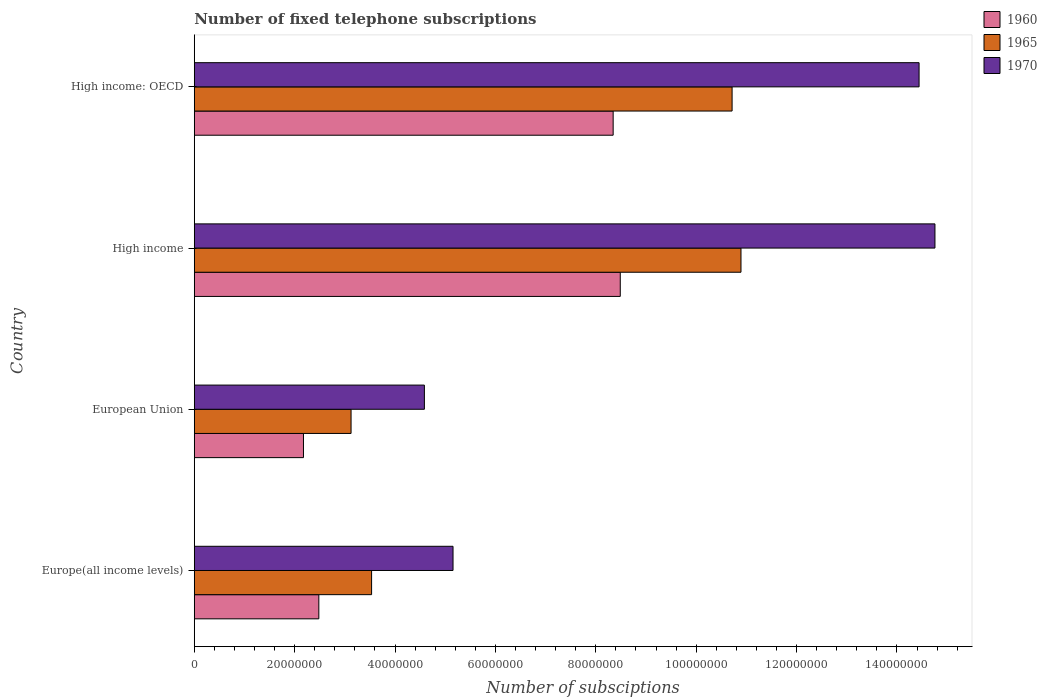How many different coloured bars are there?
Ensure brevity in your answer.  3. How many groups of bars are there?
Offer a terse response. 4. Are the number of bars on each tick of the Y-axis equal?
Your answer should be very brief. Yes. How many bars are there on the 1st tick from the top?
Your response must be concise. 3. What is the label of the 4th group of bars from the top?
Offer a very short reply. Europe(all income levels). What is the number of fixed telephone subscriptions in 1970 in European Union?
Keep it short and to the point. 4.59e+07. Across all countries, what is the maximum number of fixed telephone subscriptions in 1960?
Provide a short and direct response. 8.49e+07. Across all countries, what is the minimum number of fixed telephone subscriptions in 1965?
Provide a succinct answer. 3.12e+07. In which country was the number of fixed telephone subscriptions in 1960 maximum?
Ensure brevity in your answer.  High income. In which country was the number of fixed telephone subscriptions in 1970 minimum?
Your response must be concise. European Union. What is the total number of fixed telephone subscriptions in 1970 in the graph?
Give a very brief answer. 3.89e+08. What is the difference between the number of fixed telephone subscriptions in 1960 in Europe(all income levels) and that in High income?
Offer a terse response. -6.01e+07. What is the difference between the number of fixed telephone subscriptions in 1970 in High income: OECD and the number of fixed telephone subscriptions in 1965 in European Union?
Your answer should be compact. 1.13e+08. What is the average number of fixed telephone subscriptions in 1965 per country?
Make the answer very short. 7.07e+07. What is the difference between the number of fixed telephone subscriptions in 1960 and number of fixed telephone subscriptions in 1965 in European Union?
Make the answer very short. -9.48e+06. In how many countries, is the number of fixed telephone subscriptions in 1970 greater than 16000000 ?
Offer a very short reply. 4. What is the ratio of the number of fixed telephone subscriptions in 1965 in European Union to that in High income: OECD?
Keep it short and to the point. 0.29. Is the number of fixed telephone subscriptions in 1970 in Europe(all income levels) less than that in European Union?
Offer a terse response. No. What is the difference between the highest and the second highest number of fixed telephone subscriptions in 1965?
Offer a terse response. 1.77e+06. What is the difference between the highest and the lowest number of fixed telephone subscriptions in 1960?
Provide a succinct answer. 6.31e+07. Is the sum of the number of fixed telephone subscriptions in 1965 in High income and High income: OECD greater than the maximum number of fixed telephone subscriptions in 1970 across all countries?
Your response must be concise. Yes. What does the 2nd bar from the top in High income: OECD represents?
Make the answer very short. 1965. What does the 1st bar from the bottom in High income represents?
Ensure brevity in your answer.  1960. Is it the case that in every country, the sum of the number of fixed telephone subscriptions in 1970 and number of fixed telephone subscriptions in 1960 is greater than the number of fixed telephone subscriptions in 1965?
Offer a terse response. Yes. What is the difference between two consecutive major ticks on the X-axis?
Offer a very short reply. 2.00e+07. Are the values on the major ticks of X-axis written in scientific E-notation?
Your answer should be compact. No. Does the graph contain any zero values?
Provide a succinct answer. No. Does the graph contain grids?
Provide a short and direct response. No. How many legend labels are there?
Offer a terse response. 3. What is the title of the graph?
Keep it short and to the point. Number of fixed telephone subscriptions. What is the label or title of the X-axis?
Your response must be concise. Number of subsciptions. What is the Number of subsciptions of 1960 in Europe(all income levels)?
Provide a succinct answer. 2.48e+07. What is the Number of subsciptions in 1965 in Europe(all income levels)?
Offer a terse response. 3.53e+07. What is the Number of subsciptions in 1970 in Europe(all income levels)?
Offer a very short reply. 5.16e+07. What is the Number of subsciptions of 1960 in European Union?
Make the answer very short. 2.18e+07. What is the Number of subsciptions in 1965 in European Union?
Your answer should be very brief. 3.12e+07. What is the Number of subsciptions of 1970 in European Union?
Offer a very short reply. 4.59e+07. What is the Number of subsciptions in 1960 in High income?
Ensure brevity in your answer.  8.49e+07. What is the Number of subsciptions in 1965 in High income?
Your response must be concise. 1.09e+08. What is the Number of subsciptions in 1970 in High income?
Provide a short and direct response. 1.48e+08. What is the Number of subsciptions in 1960 in High income: OECD?
Your answer should be very brief. 8.35e+07. What is the Number of subsciptions in 1965 in High income: OECD?
Offer a terse response. 1.07e+08. What is the Number of subsciptions in 1970 in High income: OECD?
Keep it short and to the point. 1.44e+08. Across all countries, what is the maximum Number of subsciptions of 1960?
Provide a short and direct response. 8.49e+07. Across all countries, what is the maximum Number of subsciptions in 1965?
Provide a succinct answer. 1.09e+08. Across all countries, what is the maximum Number of subsciptions of 1970?
Provide a succinct answer. 1.48e+08. Across all countries, what is the minimum Number of subsciptions in 1960?
Provide a short and direct response. 2.18e+07. Across all countries, what is the minimum Number of subsciptions in 1965?
Your answer should be very brief. 3.12e+07. Across all countries, what is the minimum Number of subsciptions in 1970?
Ensure brevity in your answer.  4.59e+07. What is the total Number of subsciptions in 1960 in the graph?
Provide a short and direct response. 2.15e+08. What is the total Number of subsciptions of 1965 in the graph?
Keep it short and to the point. 2.83e+08. What is the total Number of subsciptions in 1970 in the graph?
Ensure brevity in your answer.  3.89e+08. What is the difference between the Number of subsciptions of 1960 in Europe(all income levels) and that in European Union?
Give a very brief answer. 3.06e+06. What is the difference between the Number of subsciptions of 1965 in Europe(all income levels) and that in European Union?
Provide a succinct answer. 4.09e+06. What is the difference between the Number of subsciptions in 1970 in Europe(all income levels) and that in European Union?
Make the answer very short. 5.71e+06. What is the difference between the Number of subsciptions of 1960 in Europe(all income levels) and that in High income?
Ensure brevity in your answer.  -6.01e+07. What is the difference between the Number of subsciptions of 1965 in Europe(all income levels) and that in High income?
Ensure brevity in your answer.  -7.36e+07. What is the difference between the Number of subsciptions in 1970 in Europe(all income levels) and that in High income?
Provide a succinct answer. -9.60e+07. What is the difference between the Number of subsciptions in 1960 in Europe(all income levels) and that in High income: OECD?
Your answer should be compact. -5.86e+07. What is the difference between the Number of subsciptions of 1965 in Europe(all income levels) and that in High income: OECD?
Provide a short and direct response. -7.18e+07. What is the difference between the Number of subsciptions of 1970 in Europe(all income levels) and that in High income: OECD?
Give a very brief answer. -9.29e+07. What is the difference between the Number of subsciptions in 1960 in European Union and that in High income?
Ensure brevity in your answer.  -6.31e+07. What is the difference between the Number of subsciptions of 1965 in European Union and that in High income?
Give a very brief answer. -7.77e+07. What is the difference between the Number of subsciptions in 1970 in European Union and that in High income?
Provide a short and direct response. -1.02e+08. What is the difference between the Number of subsciptions in 1960 in European Union and that in High income: OECD?
Your answer should be compact. -6.17e+07. What is the difference between the Number of subsciptions of 1965 in European Union and that in High income: OECD?
Keep it short and to the point. -7.59e+07. What is the difference between the Number of subsciptions of 1970 in European Union and that in High income: OECD?
Your answer should be compact. -9.86e+07. What is the difference between the Number of subsciptions of 1960 in High income and that in High income: OECD?
Your answer should be very brief. 1.42e+06. What is the difference between the Number of subsciptions of 1965 in High income and that in High income: OECD?
Ensure brevity in your answer.  1.77e+06. What is the difference between the Number of subsciptions in 1970 in High income and that in High income: OECD?
Your answer should be compact. 3.16e+06. What is the difference between the Number of subsciptions of 1960 in Europe(all income levels) and the Number of subsciptions of 1965 in European Union?
Give a very brief answer. -6.42e+06. What is the difference between the Number of subsciptions of 1960 in Europe(all income levels) and the Number of subsciptions of 1970 in European Union?
Provide a short and direct response. -2.10e+07. What is the difference between the Number of subsciptions in 1965 in Europe(all income levels) and the Number of subsciptions in 1970 in European Union?
Provide a short and direct response. -1.05e+07. What is the difference between the Number of subsciptions in 1960 in Europe(all income levels) and the Number of subsciptions in 1965 in High income?
Offer a very short reply. -8.41e+07. What is the difference between the Number of subsciptions of 1960 in Europe(all income levels) and the Number of subsciptions of 1970 in High income?
Offer a very short reply. -1.23e+08. What is the difference between the Number of subsciptions of 1965 in Europe(all income levels) and the Number of subsciptions of 1970 in High income?
Provide a succinct answer. -1.12e+08. What is the difference between the Number of subsciptions in 1960 in Europe(all income levels) and the Number of subsciptions in 1965 in High income: OECD?
Ensure brevity in your answer.  -8.23e+07. What is the difference between the Number of subsciptions in 1960 in Europe(all income levels) and the Number of subsciptions in 1970 in High income: OECD?
Your response must be concise. -1.20e+08. What is the difference between the Number of subsciptions in 1965 in Europe(all income levels) and the Number of subsciptions in 1970 in High income: OECD?
Make the answer very short. -1.09e+08. What is the difference between the Number of subsciptions of 1960 in European Union and the Number of subsciptions of 1965 in High income?
Your answer should be very brief. -8.72e+07. What is the difference between the Number of subsciptions in 1960 in European Union and the Number of subsciptions in 1970 in High income?
Give a very brief answer. -1.26e+08. What is the difference between the Number of subsciptions in 1965 in European Union and the Number of subsciptions in 1970 in High income?
Make the answer very short. -1.16e+08. What is the difference between the Number of subsciptions of 1960 in European Union and the Number of subsciptions of 1965 in High income: OECD?
Make the answer very short. -8.54e+07. What is the difference between the Number of subsciptions in 1960 in European Union and the Number of subsciptions in 1970 in High income: OECD?
Make the answer very short. -1.23e+08. What is the difference between the Number of subsciptions in 1965 in European Union and the Number of subsciptions in 1970 in High income: OECD?
Offer a terse response. -1.13e+08. What is the difference between the Number of subsciptions in 1960 in High income and the Number of subsciptions in 1965 in High income: OECD?
Give a very brief answer. -2.23e+07. What is the difference between the Number of subsciptions of 1960 in High income and the Number of subsciptions of 1970 in High income: OECD?
Your response must be concise. -5.95e+07. What is the difference between the Number of subsciptions of 1965 in High income and the Number of subsciptions of 1970 in High income: OECD?
Offer a very short reply. -3.55e+07. What is the average Number of subsciptions of 1960 per country?
Ensure brevity in your answer.  5.37e+07. What is the average Number of subsciptions in 1965 per country?
Your answer should be very brief. 7.07e+07. What is the average Number of subsciptions in 1970 per country?
Keep it short and to the point. 9.74e+07. What is the difference between the Number of subsciptions in 1960 and Number of subsciptions in 1965 in Europe(all income levels)?
Provide a short and direct response. -1.05e+07. What is the difference between the Number of subsciptions in 1960 and Number of subsciptions in 1970 in Europe(all income levels)?
Provide a short and direct response. -2.67e+07. What is the difference between the Number of subsciptions in 1965 and Number of subsciptions in 1970 in Europe(all income levels)?
Your answer should be compact. -1.62e+07. What is the difference between the Number of subsciptions of 1960 and Number of subsciptions of 1965 in European Union?
Give a very brief answer. -9.48e+06. What is the difference between the Number of subsciptions of 1960 and Number of subsciptions of 1970 in European Union?
Offer a very short reply. -2.41e+07. What is the difference between the Number of subsciptions in 1965 and Number of subsciptions in 1970 in European Union?
Make the answer very short. -1.46e+07. What is the difference between the Number of subsciptions of 1960 and Number of subsciptions of 1965 in High income?
Provide a succinct answer. -2.41e+07. What is the difference between the Number of subsciptions of 1960 and Number of subsciptions of 1970 in High income?
Ensure brevity in your answer.  -6.27e+07. What is the difference between the Number of subsciptions in 1965 and Number of subsciptions in 1970 in High income?
Ensure brevity in your answer.  -3.86e+07. What is the difference between the Number of subsciptions of 1960 and Number of subsciptions of 1965 in High income: OECD?
Ensure brevity in your answer.  -2.37e+07. What is the difference between the Number of subsciptions in 1960 and Number of subsciptions in 1970 in High income: OECD?
Your answer should be very brief. -6.10e+07. What is the difference between the Number of subsciptions in 1965 and Number of subsciptions in 1970 in High income: OECD?
Your answer should be compact. -3.73e+07. What is the ratio of the Number of subsciptions of 1960 in Europe(all income levels) to that in European Union?
Provide a short and direct response. 1.14. What is the ratio of the Number of subsciptions in 1965 in Europe(all income levels) to that in European Union?
Provide a short and direct response. 1.13. What is the ratio of the Number of subsciptions of 1970 in Europe(all income levels) to that in European Union?
Offer a very short reply. 1.12. What is the ratio of the Number of subsciptions of 1960 in Europe(all income levels) to that in High income?
Your answer should be very brief. 0.29. What is the ratio of the Number of subsciptions of 1965 in Europe(all income levels) to that in High income?
Ensure brevity in your answer.  0.32. What is the ratio of the Number of subsciptions in 1970 in Europe(all income levels) to that in High income?
Make the answer very short. 0.35. What is the ratio of the Number of subsciptions in 1960 in Europe(all income levels) to that in High income: OECD?
Your answer should be compact. 0.3. What is the ratio of the Number of subsciptions in 1965 in Europe(all income levels) to that in High income: OECD?
Offer a very short reply. 0.33. What is the ratio of the Number of subsciptions of 1970 in Europe(all income levels) to that in High income: OECD?
Provide a short and direct response. 0.36. What is the ratio of the Number of subsciptions of 1960 in European Union to that in High income?
Make the answer very short. 0.26. What is the ratio of the Number of subsciptions of 1965 in European Union to that in High income?
Make the answer very short. 0.29. What is the ratio of the Number of subsciptions of 1970 in European Union to that in High income?
Your answer should be compact. 0.31. What is the ratio of the Number of subsciptions in 1960 in European Union to that in High income: OECD?
Your response must be concise. 0.26. What is the ratio of the Number of subsciptions of 1965 in European Union to that in High income: OECD?
Offer a very short reply. 0.29. What is the ratio of the Number of subsciptions in 1970 in European Union to that in High income: OECD?
Your answer should be very brief. 0.32. What is the ratio of the Number of subsciptions of 1960 in High income to that in High income: OECD?
Offer a very short reply. 1.02. What is the ratio of the Number of subsciptions in 1965 in High income to that in High income: OECD?
Give a very brief answer. 1.02. What is the ratio of the Number of subsciptions of 1970 in High income to that in High income: OECD?
Offer a terse response. 1.02. What is the difference between the highest and the second highest Number of subsciptions of 1960?
Give a very brief answer. 1.42e+06. What is the difference between the highest and the second highest Number of subsciptions in 1965?
Provide a short and direct response. 1.77e+06. What is the difference between the highest and the second highest Number of subsciptions of 1970?
Offer a terse response. 3.16e+06. What is the difference between the highest and the lowest Number of subsciptions in 1960?
Offer a terse response. 6.31e+07. What is the difference between the highest and the lowest Number of subsciptions in 1965?
Ensure brevity in your answer.  7.77e+07. What is the difference between the highest and the lowest Number of subsciptions of 1970?
Keep it short and to the point. 1.02e+08. 